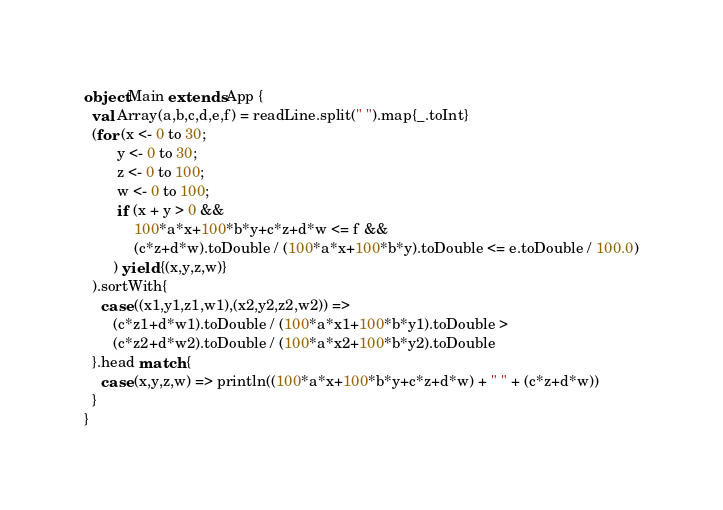Convert code to text. <code><loc_0><loc_0><loc_500><loc_500><_Scala_>object Main extends App {
  val Array(a,b,c,d,e,f) = readLine.split(" ").map{_.toInt}
  (for (x <- 0 to 30;
        y <- 0 to 30;
        z <- 0 to 100;
        w <- 0 to 100;
        if (x + y > 0 &&
            100*a*x+100*b*y+c*z+d*w <= f &&
            (c*z+d*w).toDouble / (100*a*x+100*b*y).toDouble <= e.toDouble / 100.0)
       ) yield {(x,y,z,w)}
  ).sortWith{
    case ((x1,y1,z1,w1),(x2,y2,z2,w2)) =>
       (c*z1+d*w1).toDouble / (100*a*x1+100*b*y1).toDouble >
       (c*z2+d*w2).toDouble / (100*a*x2+100*b*y2).toDouble
  }.head match {
    case (x,y,z,w) => println((100*a*x+100*b*y+c*z+d*w) + " " + (c*z+d*w))
  }                        
}</code> 